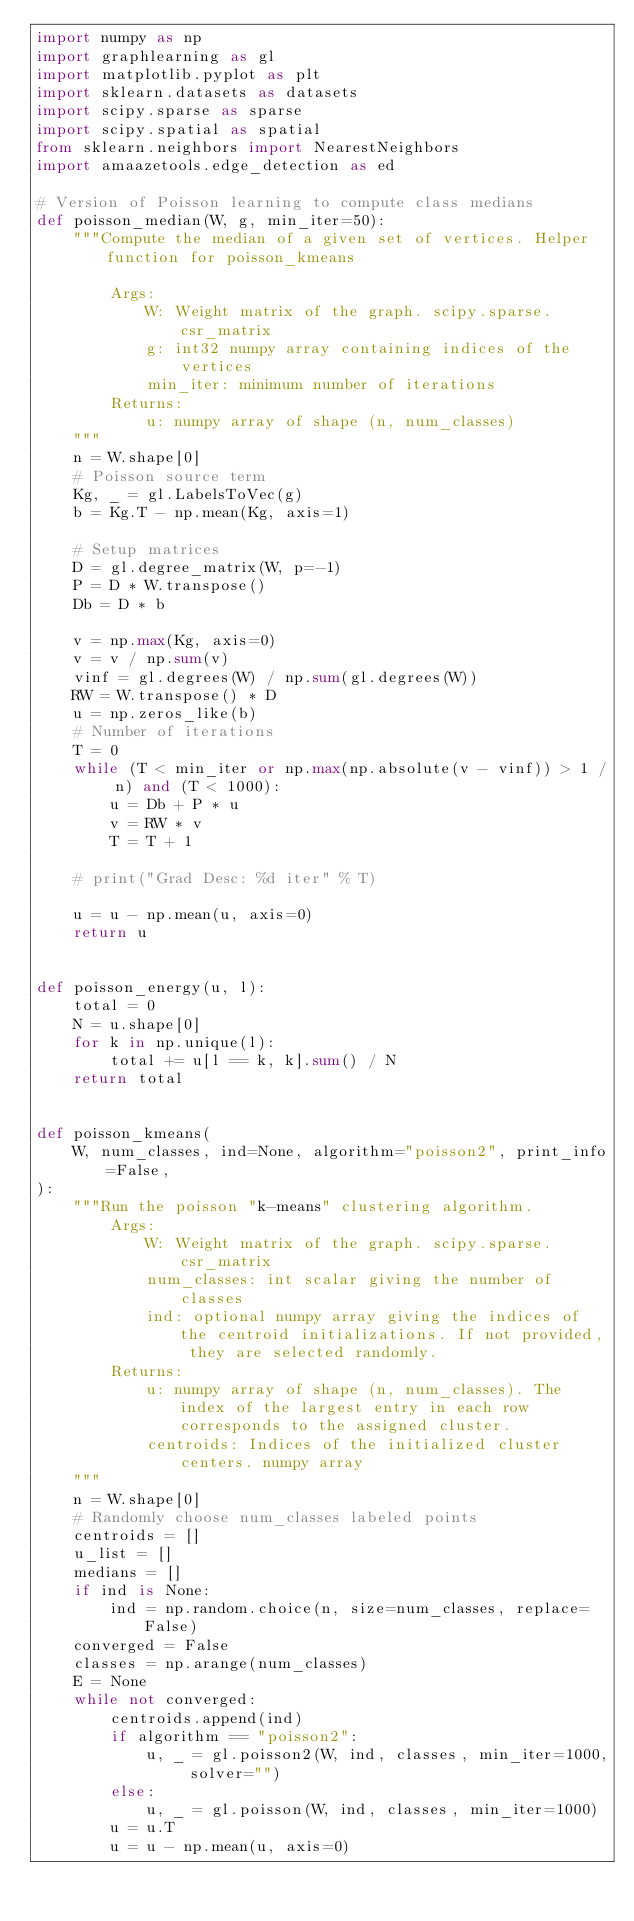Convert code to text. <code><loc_0><loc_0><loc_500><loc_500><_Python_>import numpy as np
import graphlearning as gl
import matplotlib.pyplot as plt
import sklearn.datasets as datasets
import scipy.sparse as sparse
import scipy.spatial as spatial
from sklearn.neighbors import NearestNeighbors
import amaazetools.edge_detection as ed

# Version of Poisson learning to compute class medians
def poisson_median(W, g, min_iter=50):
    """Compute the median of a given set of vertices. Helper function for poisson_kmeans

        Args:
            W: Weight matrix of the graph. scipy.sparse.csr_matrix
            g: int32 numpy array containing indices of the vertices
            min_iter: minimum number of iterations
        Returns:
            u: numpy array of shape (n, num_classes)
    """
    n = W.shape[0]
    # Poisson source term
    Kg, _ = gl.LabelsToVec(g)
    b = Kg.T - np.mean(Kg, axis=1)

    # Setup matrices
    D = gl.degree_matrix(W, p=-1)
    P = D * W.transpose()
    Db = D * b

    v = np.max(Kg, axis=0)
    v = v / np.sum(v)
    vinf = gl.degrees(W) / np.sum(gl.degrees(W))
    RW = W.transpose() * D
    u = np.zeros_like(b)
    # Number of iterations
    T = 0
    while (T < min_iter or np.max(np.absolute(v - vinf)) > 1 / n) and (T < 1000):
        u = Db + P * u
        v = RW * v
        T = T + 1

    # print("Grad Desc: %d iter" % T)

    u = u - np.mean(u, axis=0)
    return u


def poisson_energy(u, l):
    total = 0
    N = u.shape[0]
    for k in np.unique(l):
        total += u[l == k, k].sum() / N
    return total


def poisson_kmeans(
    W, num_classes, ind=None, algorithm="poisson2", print_info=False,
):
    """Run the poisson "k-means" clustering algorithm.
        Args:
            W: Weight matrix of the graph. scipy.sparse.csr_matrix
            num_classes: int scalar giving the number of classes
            ind: optional numpy array giving the indices of the centroid initializations. If not provided, they are selected randomly.
        Returns:
            u: numpy array of shape (n, num_classes). The index of the largest entry in each row corresponds to the assigned cluster.
            centroids: Indices of the initialized cluster centers. numpy array
    """
    n = W.shape[0]
    # Randomly choose num_classes labeled points
    centroids = []
    u_list = []
    medians = []
    if ind is None:
        ind = np.random.choice(n, size=num_classes, replace=False)
    converged = False
    classes = np.arange(num_classes)
    E = None
    while not converged:
        centroids.append(ind)
        if algorithm == "poisson2":
            u, _ = gl.poisson2(W, ind, classes, min_iter=1000, solver="")
        else:
            u, _ = gl.poisson(W, ind, classes, min_iter=1000)
        u = u.T
        u = u - np.mean(u, axis=0)</code> 